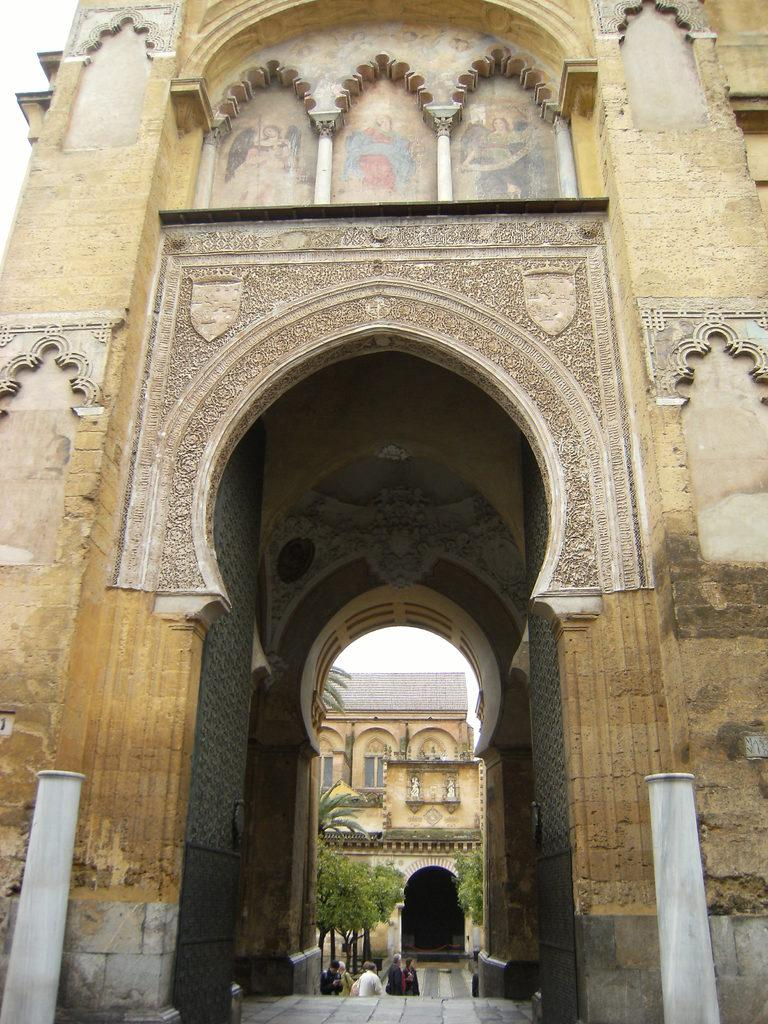What is the main subject of the image? The main subject of the image is the entrance of an old monument. What can be found beyond the entrance? The entrance leads to another monument. Can you see a train passing by the monument in the image? There is no train present in the image. Is the person's father standing next to the monument in the image? There is no person or father mentioned in the image, only the entrance of an old monument and another monument. 